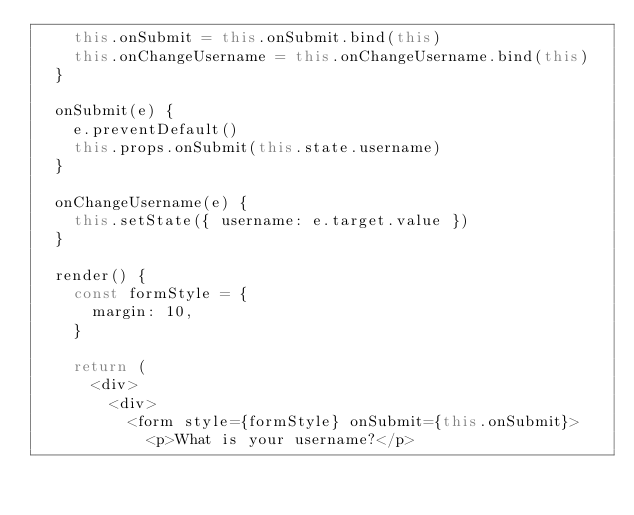<code> <loc_0><loc_0><loc_500><loc_500><_JavaScript_>    this.onSubmit = this.onSubmit.bind(this)
    this.onChangeUsername = this.onChangeUsername.bind(this)
  }

  onSubmit(e) {
    e.preventDefault()
    this.props.onSubmit(this.state.username)
  }

  onChangeUsername(e) {
    this.setState({ username: e.target.value })
  }

  render() {
    const formStyle = {
      margin: 10,
    }
    
    return (
      <div>
        <div>
          <form style={formStyle} onSubmit={this.onSubmit}>
            <p>What is your username?</p></code> 